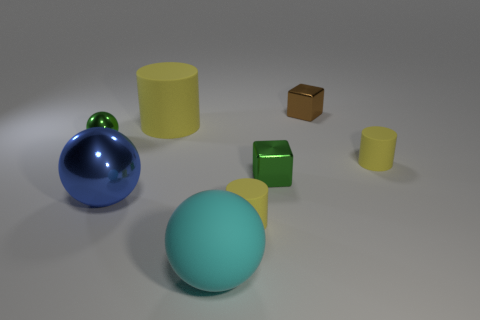Subtract all yellow cylinders. How many were subtracted if there are1yellow cylinders left? 2 Add 1 big spheres. How many objects exist? 9 Subtract all cubes. How many objects are left? 6 Add 2 metal cubes. How many metal cubes exist? 4 Subtract 1 green spheres. How many objects are left? 7 Subtract all blue balls. Subtract all yellow spheres. How many objects are left? 7 Add 6 small green objects. How many small green objects are left? 8 